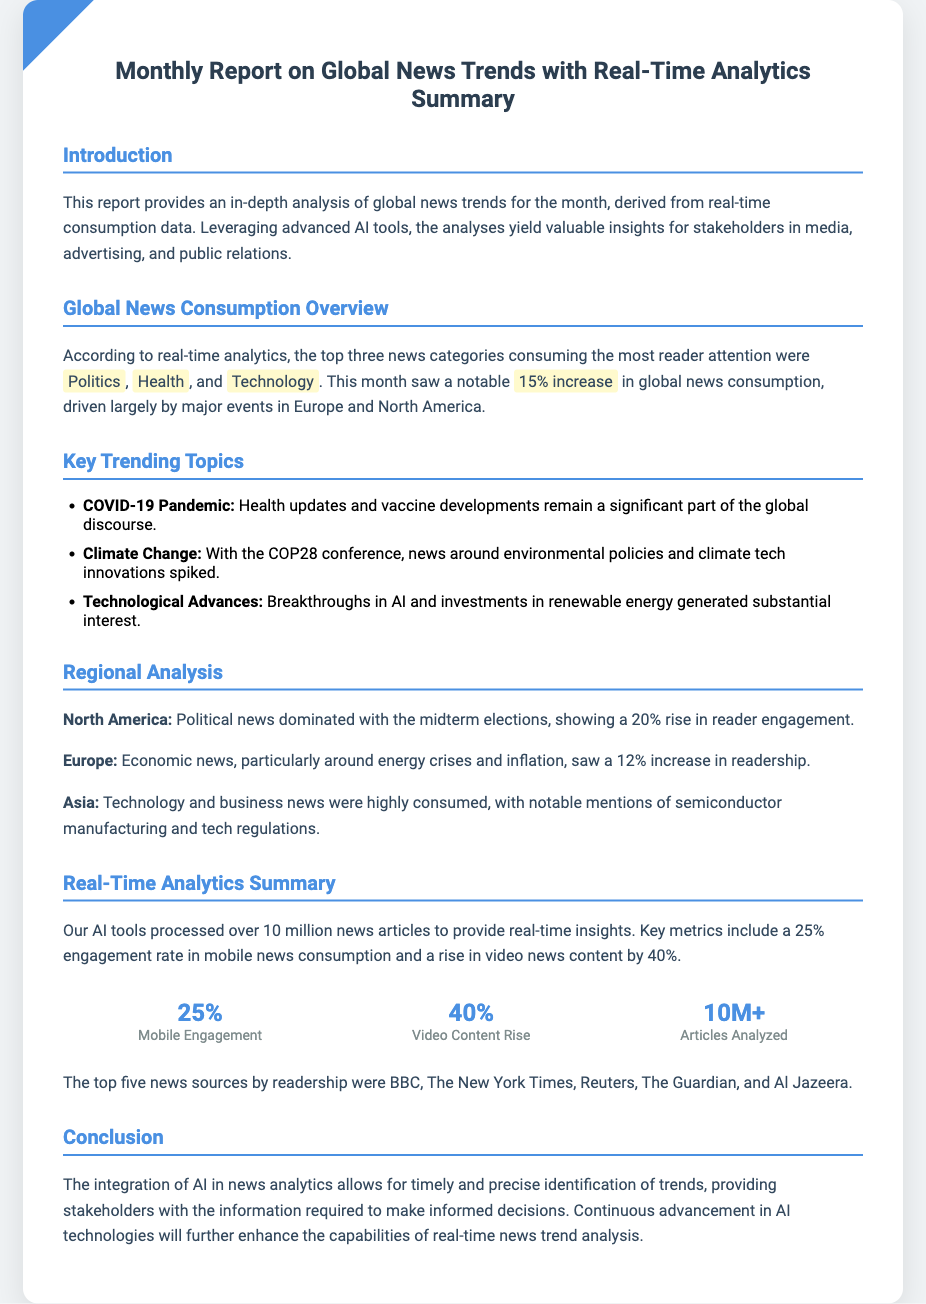What are the top three news categories? The document states that the top three news categories consuming the most reader attention are Politics, Health, and Technology.
Answer: Politics, Health, Technology What percentage increase was observed in global news consumption? The report mentions a notable 15% increase in global news consumption.
Answer: 15% Which major event influenced the news consumption spike in North America? The document indicates that political news dominated due to the midterm elections.
Answer: Midterm elections How many articles were analyzed? The report states that our AI tools processed over 10 million news articles.
Answer: 10M+ What was the engagement rate in mobile news consumption? The document indicates a 25% engagement rate in mobile news consumption.
Answer: 25% Which news source had the highest readership? The report lists BBC as the top news source by readership.
Answer: BBC What trend was observed in video news content? The document mentions a rise in video news content by 40%.
Answer: 40% Which region saw a 12% increase in readership related to economic news? The report highlights Europe as the region with a 12% increase in readership for economic news.
Answer: Europe 